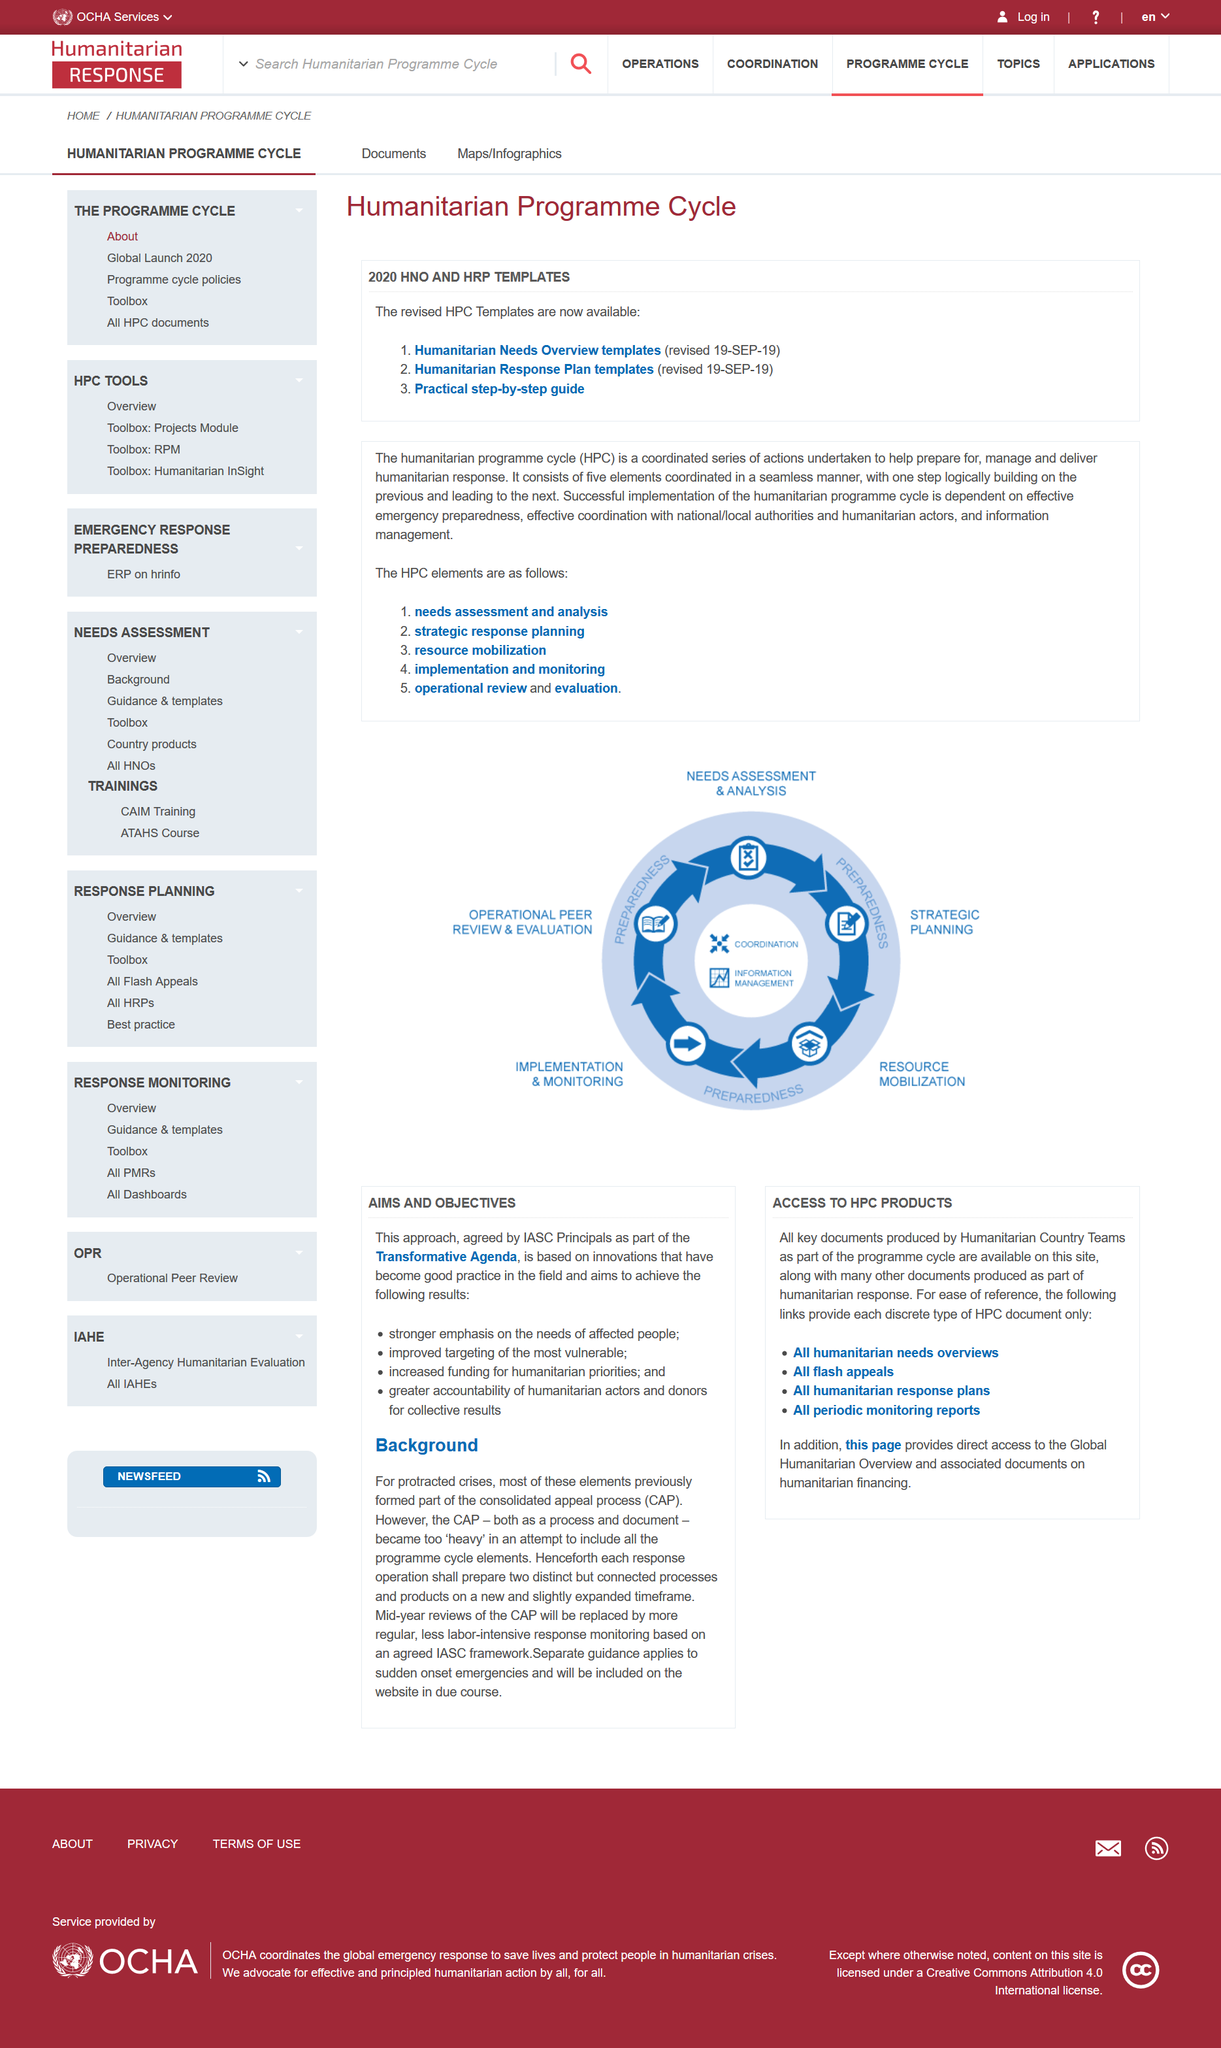Indicate a few pertinent items in this graphic. There are a total of 5 elements in the HPC. The Humanitarian Programme Cycle is a systematic process consisting of various stages undertaken to provide humanitarian assistance in preparation, response, and recovery from crisis situations. The Humanitarian Programme Cycle is the name of the programme. 